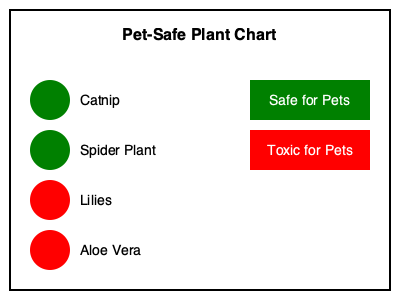Based on the color-coded chart provided, which of the listed plants would be safe to include in a pet-friendly garden? To determine which plants are safe for a pet-friendly garden, we need to analyze the color-coded chart:

1. The chart uses a simple color-coding system:
   - Green circles indicate plants that are safe for pets
   - Red circles indicate plants that are toxic for pets

2. Let's examine each plant listed in the chart:
   a. Catnip: Green circle - safe for pets
   b. Spider Plant: Green circle - safe for pets
   c. Lilies: Red circle - toxic for pets
   d. Aloe Vera: Red circle - toxic for pets

3. The legend at the bottom right of the chart confirms:
   - Green = Safe for Pets
   - Red = Toxic for Pets

4. Therefore, only the plants marked with green circles are safe to include in a pet-friendly garden.

5. Reviewing the safe plants:
   - Catnip
   - Spider Plant

These are the only two plants from the list that would be appropriate for a pet-friendly garden.
Answer: Catnip and Spider Plant 